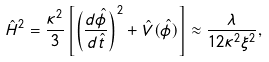<formula> <loc_0><loc_0><loc_500><loc_500>\hat { H } ^ { 2 } = \frac { \kappa ^ { 2 } } 3 \left [ \left ( \frac { d \hat { \phi } } { d \hat { t } } \right ) ^ { 2 } + \hat { V } ( \hat { \phi } ) \right ] \approx \frac { \lambda } { 1 2 \kappa ^ { 2 } \xi ^ { 2 } } ,</formula> 